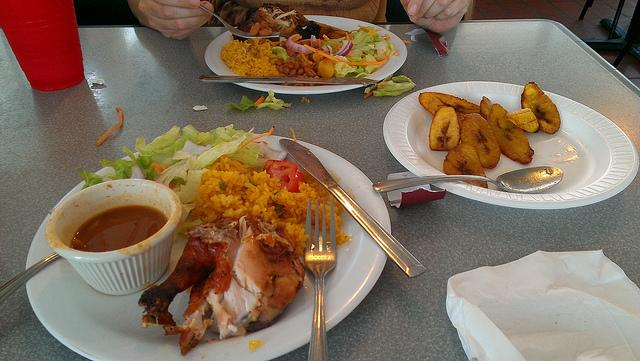What type of rice is on the dishes? spanish 